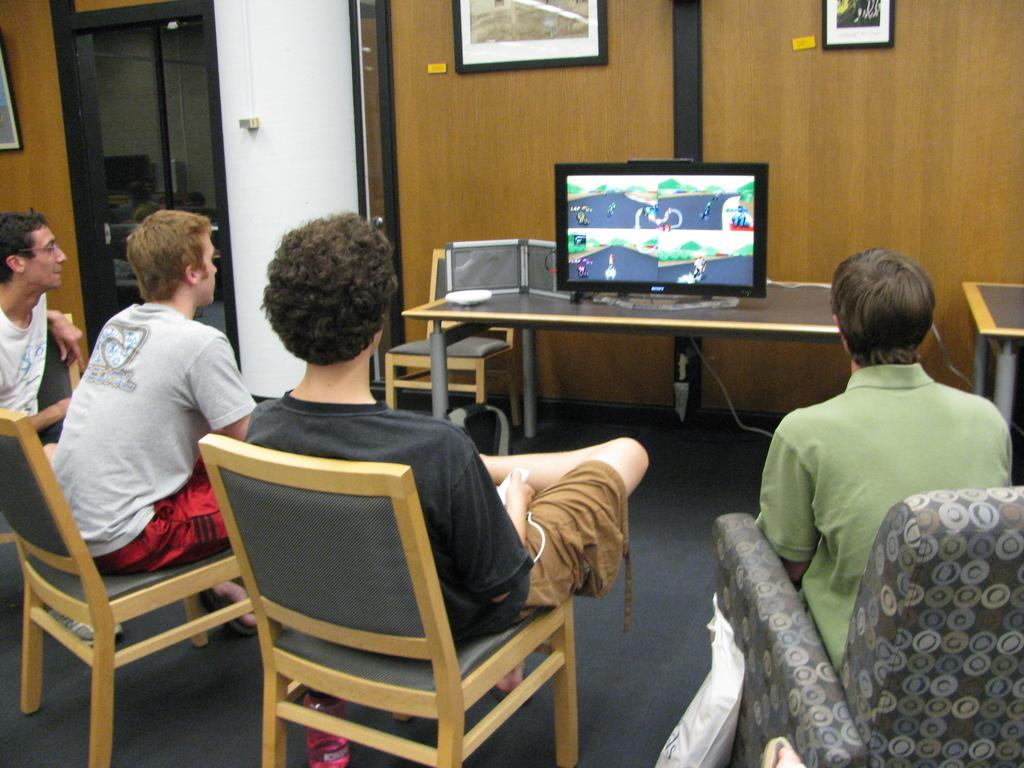How many people are in the image? There are four persons in the image. What are the persons doing in the image? The persons are sitting on chairs and looking at a television. Where is the television placed in the image? The television is placed on a table. What can be seen in the background of the image? A: There is a door, a wall, and frames visible in the background. What is the grade of the structure in the image? There is no structure present in the image, so it is not possible to determine its grade. 